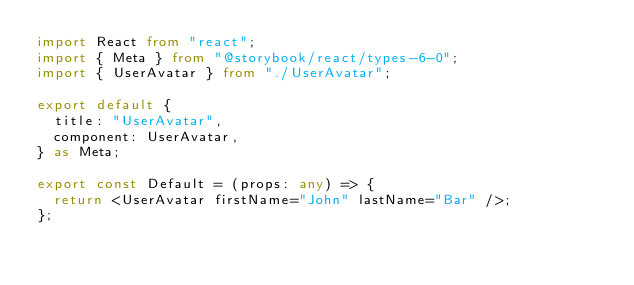Convert code to text. <code><loc_0><loc_0><loc_500><loc_500><_TypeScript_>import React from "react";
import { Meta } from "@storybook/react/types-6-0";
import { UserAvatar } from "./UserAvatar";

export default {
  title: "UserAvatar",
  component: UserAvatar,
} as Meta;

export const Default = (props: any) => {
  return <UserAvatar firstName="John" lastName="Bar" />;
};
</code> 